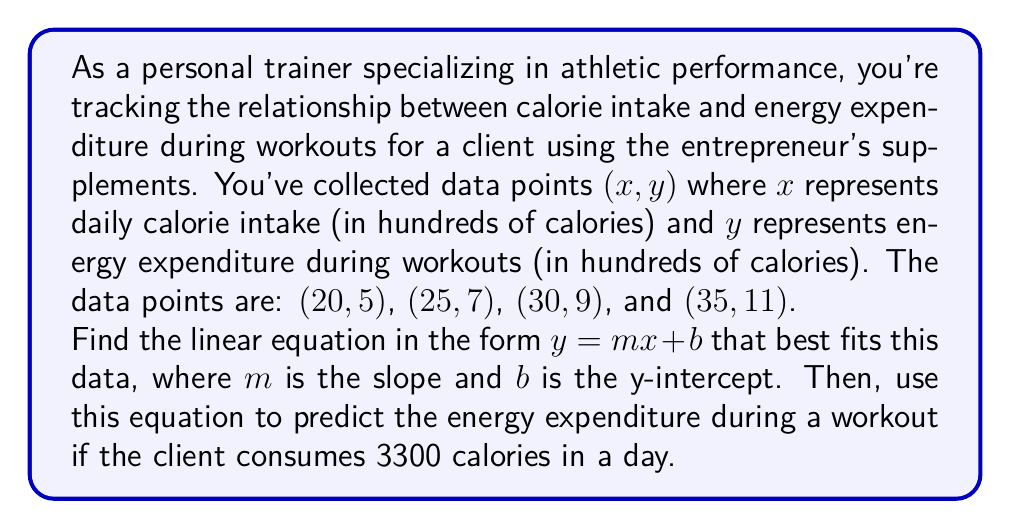Help me with this question. To find the linear equation, we'll use the slope-intercept form $y = mx + b$. Let's follow these steps:

1. Calculate the slope (m):
   $m = \frac{y_2 - y_1}{x_2 - x_1}$
   Using the first and last data points: (20, 5) and (35, 11)
   $m = \frac{11 - 5}{35 - 20} = \frac{6}{15} = 0.4$

2. Use the point-slope form to find b:
   $y - y_1 = m(x - x_1)$
   Using the point (20, 5):
   $5 = 0.4(20) + b$
   $5 = 8 + b$
   $b = 5 - 8 = -3$

3. The linear equation is:
   $y = 0.4x - 3$

4. To predict energy expenditure for 3300 calories:
   $x = 33$ (as we're working in hundreds of calories)
   $y = 0.4(33) - 3 = 13.2 - 3 = 10.2$

Therefore, the predicted energy expenditure is 1020 calories (10.2 hundred calories).
Answer: The linear equation is $y = 0.4x - 3$, and the predicted energy expenditure for a 3300-calorie intake is 1020 calories. 